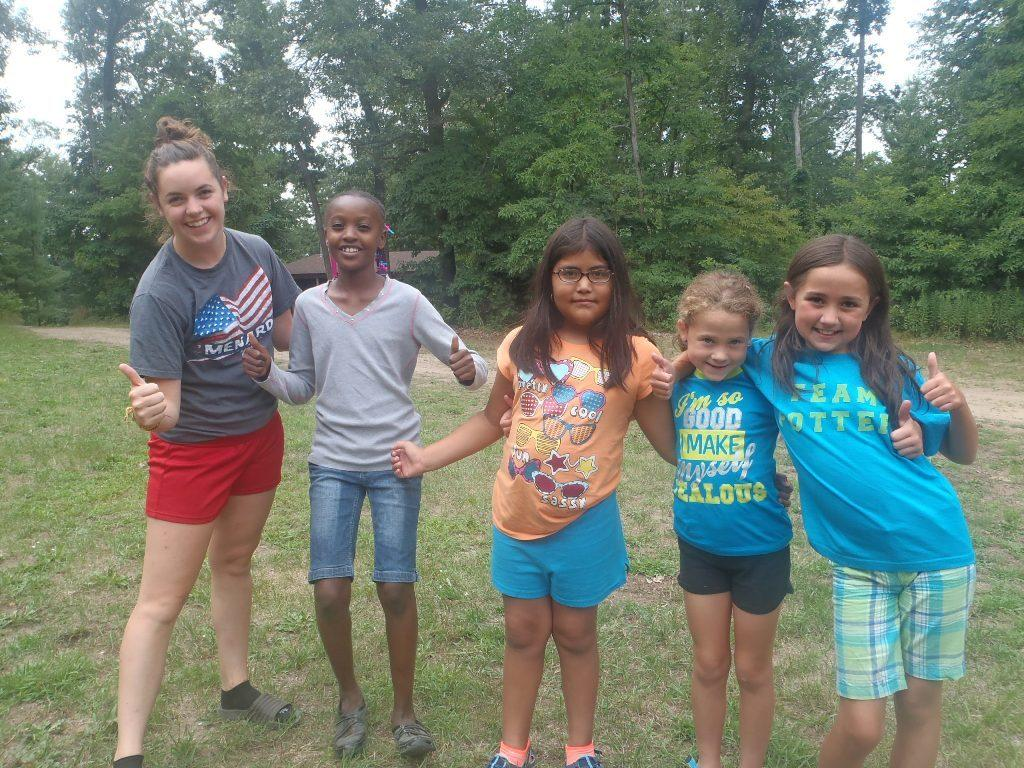What are the people in the image doing? The people in the image are standing on the grass. What can be seen in the background of the image? There is a shed and trees visible in the background. What arithmetic problem is being solved by the trees in the background? There is no arithmetic problem being solved by the trees in the background; they are simply trees in the image. 